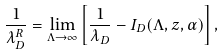Convert formula to latex. <formula><loc_0><loc_0><loc_500><loc_500>\frac { 1 } { \lambda _ { D } ^ { R } } = \lim _ { \Lambda \to \infty } \left [ \frac { 1 } { \lambda _ { D } } - I _ { D } ( \Lambda , z , \alpha ) \right ] ,</formula> 